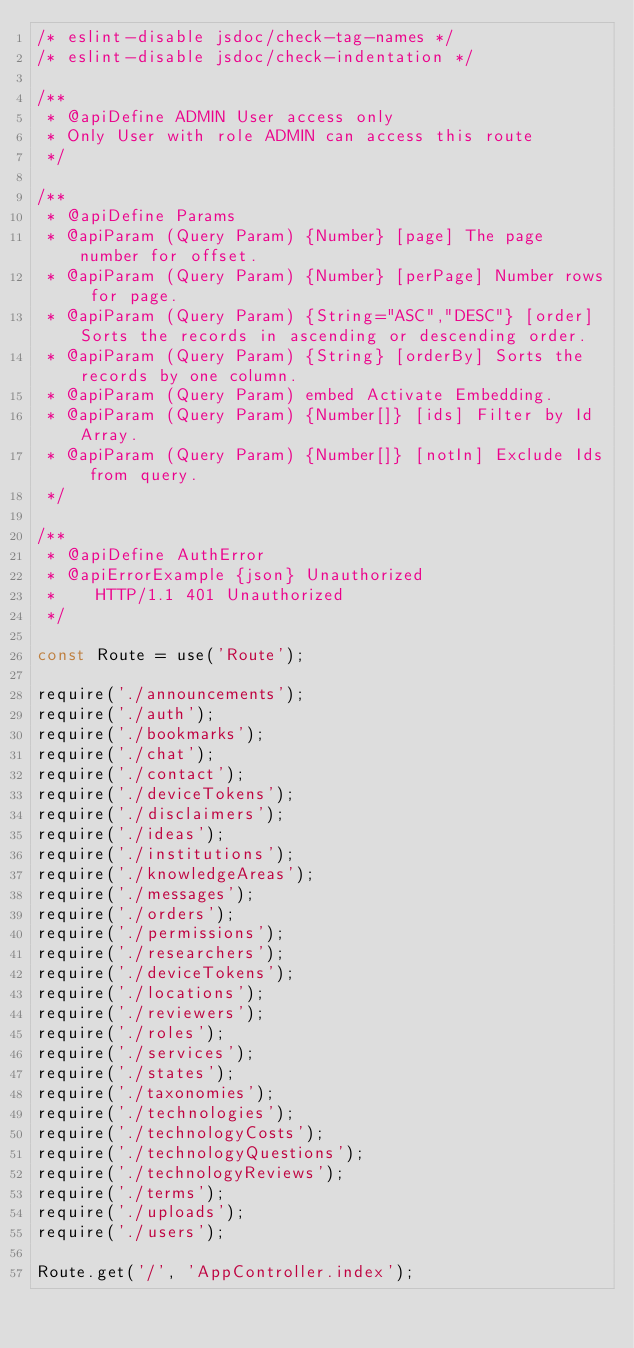<code> <loc_0><loc_0><loc_500><loc_500><_JavaScript_>/* eslint-disable jsdoc/check-tag-names */
/* eslint-disable jsdoc/check-indentation */

/**
 * @apiDefine ADMIN User access only
 * Only User with role ADMIN can access this route
 */

/**
 * @apiDefine Params
 * @apiParam (Query Param) {Number} [page] The page number for offset.
 * @apiParam (Query Param) {Number} [perPage] Number rows for page.
 * @apiParam (Query Param) {String="ASC","DESC"} [order] Sorts the records in ascending or descending order.
 * @apiParam (Query Param) {String} [orderBy] Sorts the records by one column.
 * @apiParam (Query Param) embed Activate Embedding.
 * @apiParam (Query Param) {Number[]} [ids] Filter by Id Array.
 * @apiParam (Query Param) {Number[]} [notIn] Exclude Ids from query.
 */

/**
 * @apiDefine AuthError
 * @apiErrorExample {json} Unauthorized
 *    HTTP/1.1 401 Unauthorized
 */

const Route = use('Route');

require('./announcements');
require('./auth');
require('./bookmarks');
require('./chat');
require('./contact');
require('./deviceTokens');
require('./disclaimers');
require('./ideas');
require('./institutions');
require('./knowledgeAreas');
require('./messages');
require('./orders');
require('./permissions');
require('./researchers');
require('./deviceTokens');
require('./locations');
require('./reviewers');
require('./roles');
require('./services');
require('./states');
require('./taxonomies');
require('./technologies');
require('./technologyCosts');
require('./technologyQuestions');
require('./technologyReviews');
require('./terms');
require('./uploads');
require('./users');

Route.get('/', 'AppController.index');
</code> 